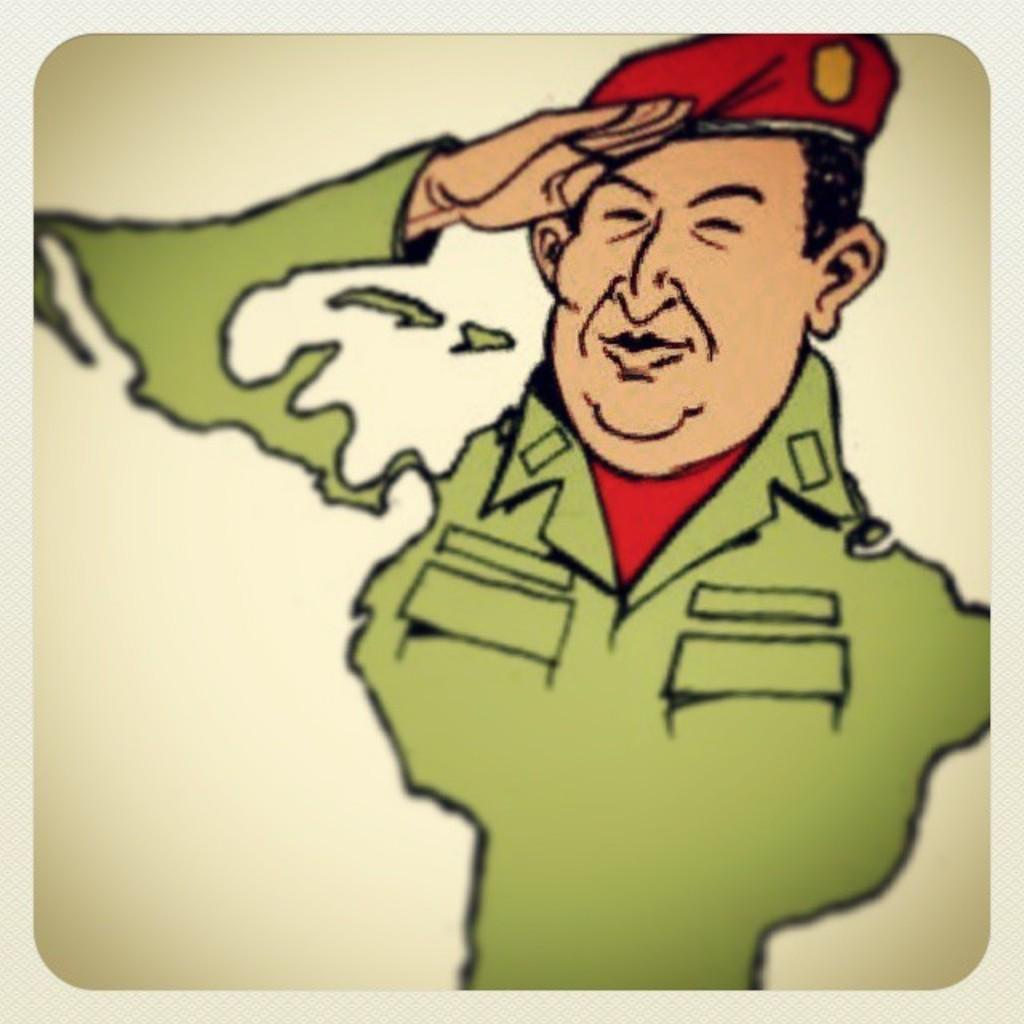What type of image is present in the picture? There is a cartoon image of a person in the image. What can be seen on the head of the person in the image? The person in the image is wearing a cap. What type of ring can be seen on the person's finger in the image? There is no ring visible on the person's finger in the image. Can you tell me how many doors are present in the image? There are no doors present in the image; it features a cartoon image of a person wearing a cap. 